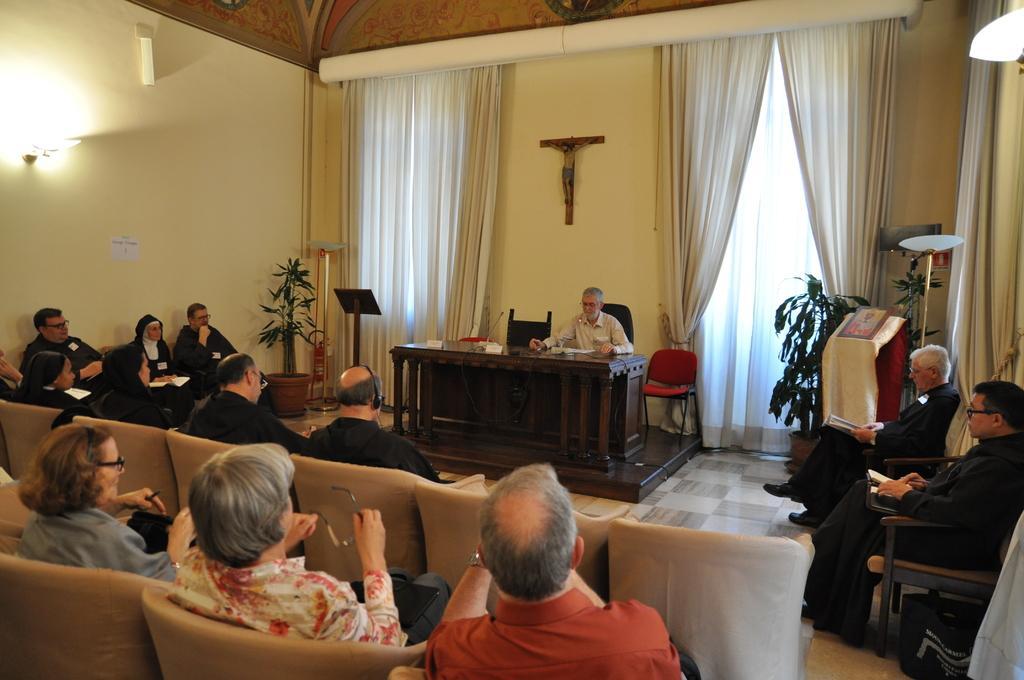Describe this image in one or two sentences. In the image there is a desk in the middle of the room and there are people sitting in the chairs in front of the desk. Behind the desk there is a man sitting in chair and talking with the people who are in front of him. At the back side there is wall,curtain and jesus symbol. To the left side top corner there is light. At the bottom of the floor there are plants. 